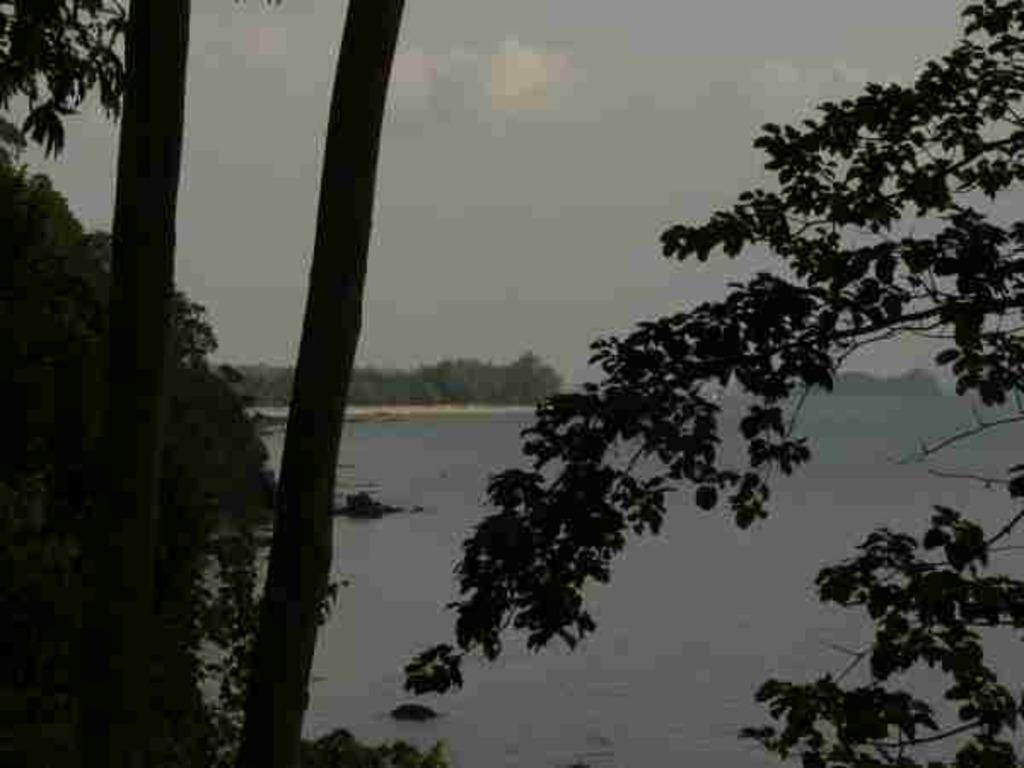Describe this image in one or two sentences. In this image we can see sea, trees and sky with clouds. 